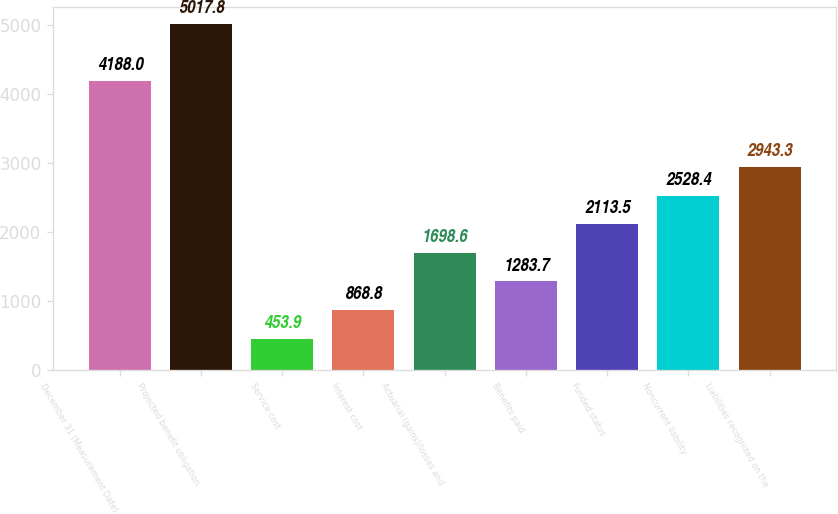Convert chart to OTSL. <chart><loc_0><loc_0><loc_500><loc_500><bar_chart><fcel>December 31 (Measurement Date)<fcel>Projected benefit obligation<fcel>Service cost<fcel>Interest cost<fcel>Actuarial (gains)/losses and<fcel>Benefits paid<fcel>Funded status<fcel>Noncurrent liability<fcel>Liabilities recognized on the<nl><fcel>4188<fcel>5017.8<fcel>453.9<fcel>868.8<fcel>1698.6<fcel>1283.7<fcel>2113.5<fcel>2528.4<fcel>2943.3<nl></chart> 